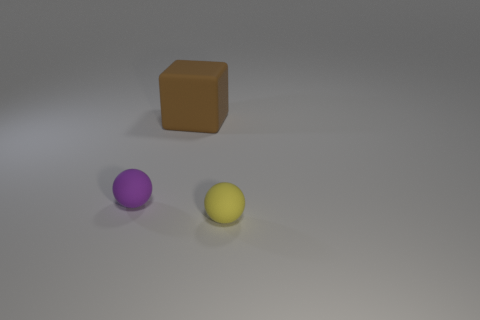Are there any other things that have the same shape as the big brown thing?
Provide a succinct answer. No. There is another matte sphere that is the same size as the yellow rubber sphere; what is its color?
Keep it short and to the point. Purple. What color is the matte cube?
Ensure brevity in your answer.  Brown. What is the small thing that is on the left side of the tiny yellow rubber ball made of?
Your answer should be compact. Rubber. Is the number of small rubber spheres that are behind the large brown matte cube less than the number of big objects?
Your response must be concise. Yes. Is there a large red shiny cylinder?
Your answer should be compact. No. What color is the other small thing that is the same shape as the yellow object?
Offer a terse response. Purple. Does the brown rubber thing have the same size as the purple matte object?
Make the answer very short. No. The brown thing that is the same material as the purple thing is what shape?
Provide a short and direct response. Cube. How many other things are there of the same shape as the large rubber object?
Your answer should be very brief. 0. 